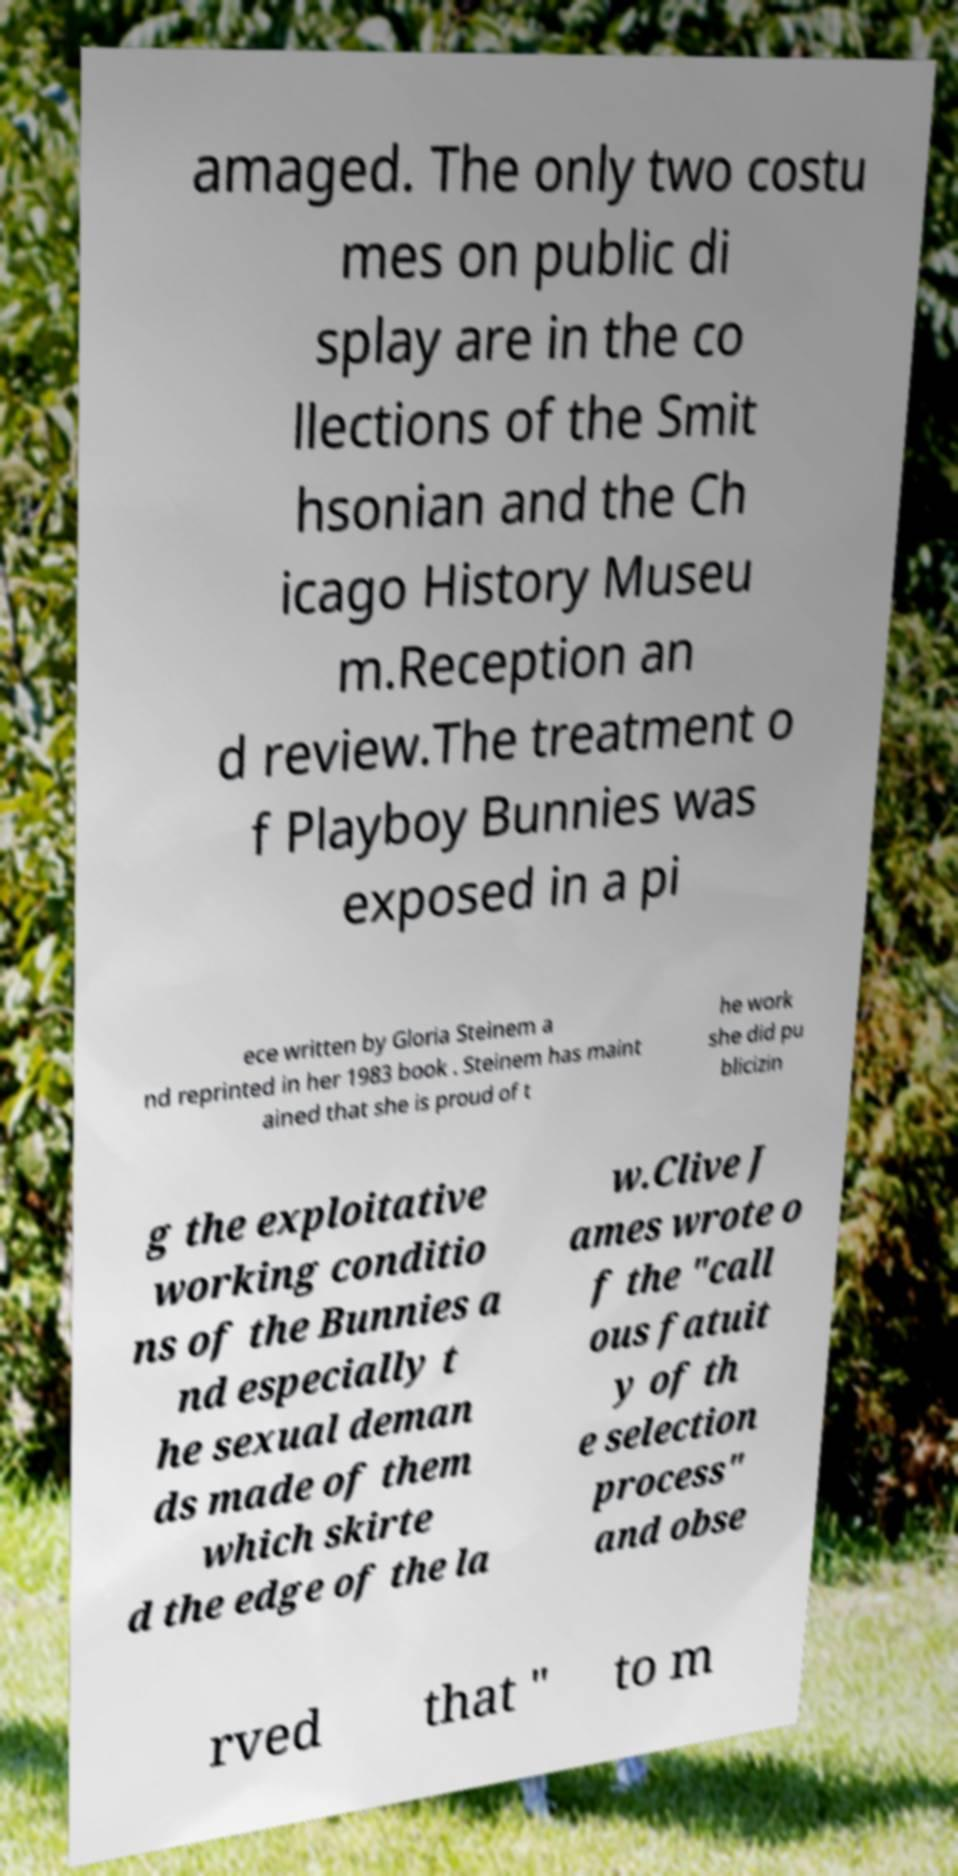For documentation purposes, I need the text within this image transcribed. Could you provide that? amaged. The only two costu mes on public di splay are in the co llections of the Smit hsonian and the Ch icago History Museu m.Reception an d review.The treatment o f Playboy Bunnies was exposed in a pi ece written by Gloria Steinem a nd reprinted in her 1983 book . Steinem has maint ained that she is proud of t he work she did pu blicizin g the exploitative working conditio ns of the Bunnies a nd especially t he sexual deman ds made of them which skirte d the edge of the la w.Clive J ames wrote o f the "call ous fatuit y of th e selection process" and obse rved that " to m 